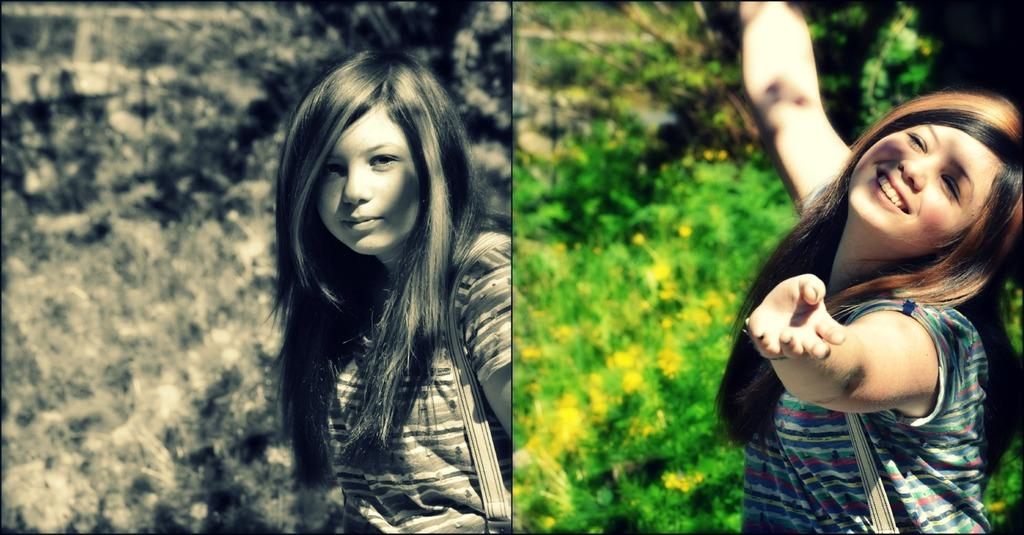What is the composition of the image? The image is a collage of two pictures. What can be seen in the first picture? In one picture, there is a girl. What is a common feature in both pictures? In both pictures, there are plants in the background. How are the colors represented in one of the pictures? One picture is in black and white color. What type of clouds can be seen in the image? There are no clouds visible in the image, as it is a collage of two pictures featuring a girl and plants in the background. Is there a battle scene depicted in the image? No, there is no battle scene present in the image; it consists of a girl and plants in the background. 